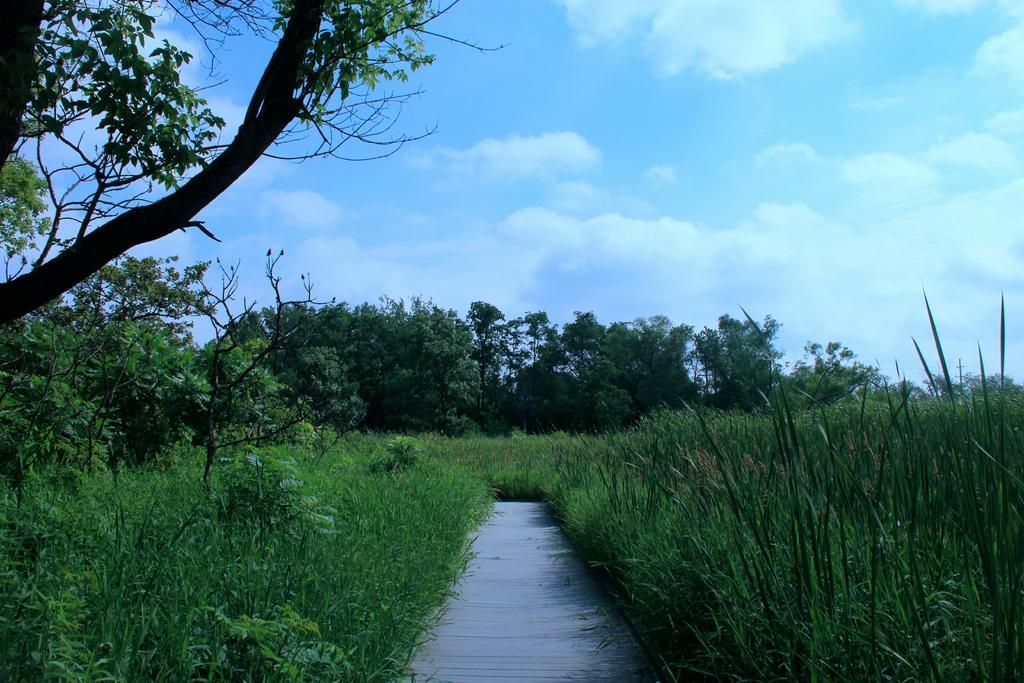What type of vegetation can be seen in the image? There are trees in the image. What is visible at the top of the image? The sky is visible at the top of the image. What can be seen in the sky? There are clouds in the sky. What type of ground cover is present at the bottom of the image? Grass is present at the bottom of the image. What type of bell can be seen hanging from the tree in the image? There is no bell present in the image; it only features trees, clouds, and grass. What type of celery is growing in the grass at the bottom of the image? There is no celery present in the image; it only features grass. 